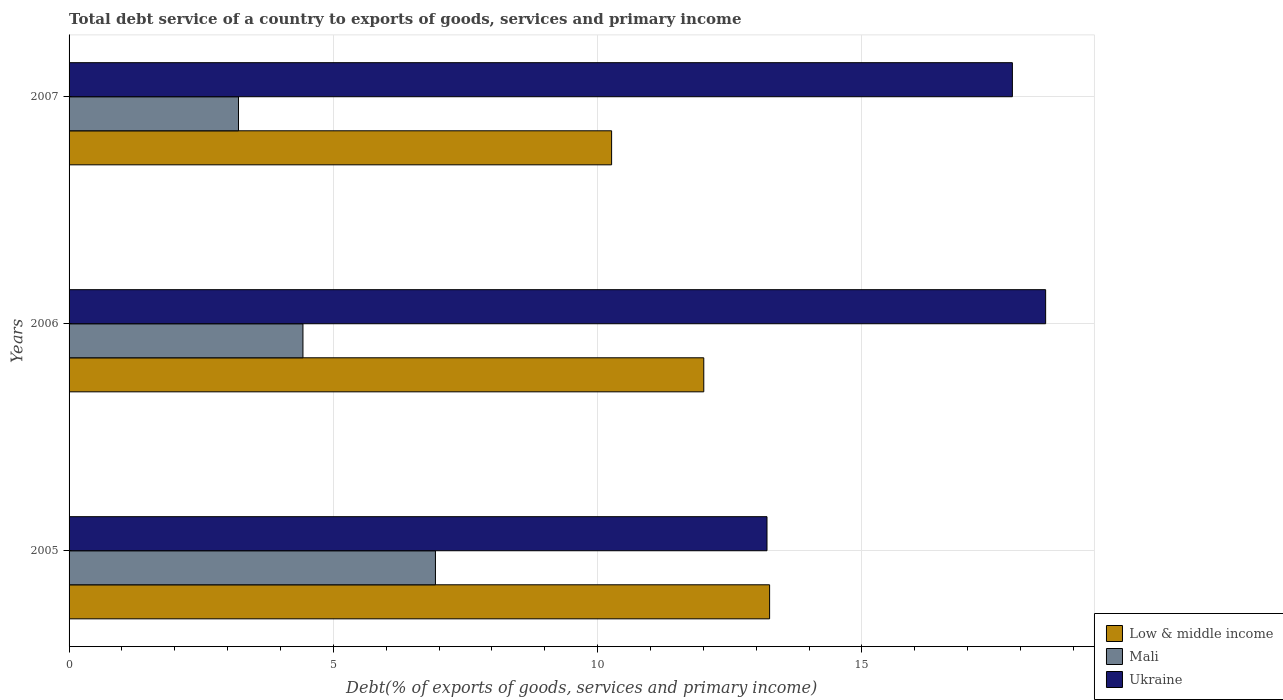How many different coloured bars are there?
Provide a succinct answer. 3. Are the number of bars per tick equal to the number of legend labels?
Provide a succinct answer. Yes. How many bars are there on the 1st tick from the top?
Your response must be concise. 3. What is the label of the 2nd group of bars from the top?
Your answer should be compact. 2006. In how many cases, is the number of bars for a given year not equal to the number of legend labels?
Offer a terse response. 0. What is the total debt service in Ukraine in 2007?
Make the answer very short. 17.85. Across all years, what is the maximum total debt service in Low & middle income?
Your answer should be very brief. 13.25. Across all years, what is the minimum total debt service in Ukraine?
Keep it short and to the point. 13.2. What is the total total debt service in Ukraine in the graph?
Your answer should be very brief. 49.52. What is the difference between the total debt service in Low & middle income in 2006 and that in 2007?
Your answer should be compact. 1.74. What is the difference between the total debt service in Mali in 2006 and the total debt service in Low & middle income in 2005?
Provide a succinct answer. -8.83. What is the average total debt service in Low & middle income per year?
Your answer should be very brief. 11.84. In the year 2006, what is the difference between the total debt service in Mali and total debt service in Low & middle income?
Your answer should be very brief. -7.58. What is the ratio of the total debt service in Ukraine in 2005 to that in 2006?
Make the answer very short. 0.71. Is the total debt service in Low & middle income in 2005 less than that in 2006?
Provide a short and direct response. No. What is the difference between the highest and the second highest total debt service in Low & middle income?
Offer a very short reply. 1.25. What is the difference between the highest and the lowest total debt service in Ukraine?
Make the answer very short. 5.27. What does the 2nd bar from the top in 2005 represents?
Offer a very short reply. Mali. What does the 3rd bar from the bottom in 2006 represents?
Give a very brief answer. Ukraine. Is it the case that in every year, the sum of the total debt service in Ukraine and total debt service in Mali is greater than the total debt service in Low & middle income?
Your answer should be compact. Yes. How many bars are there?
Give a very brief answer. 9. How many years are there in the graph?
Provide a short and direct response. 3. Does the graph contain grids?
Make the answer very short. Yes. Where does the legend appear in the graph?
Ensure brevity in your answer.  Bottom right. How are the legend labels stacked?
Make the answer very short. Vertical. What is the title of the graph?
Make the answer very short. Total debt service of a country to exports of goods, services and primary income. What is the label or title of the X-axis?
Provide a short and direct response. Debt(% of exports of goods, services and primary income). What is the label or title of the Y-axis?
Your answer should be very brief. Years. What is the Debt(% of exports of goods, services and primary income) in Low & middle income in 2005?
Your response must be concise. 13.25. What is the Debt(% of exports of goods, services and primary income) in Mali in 2005?
Your answer should be very brief. 6.93. What is the Debt(% of exports of goods, services and primary income) in Ukraine in 2005?
Provide a succinct answer. 13.2. What is the Debt(% of exports of goods, services and primary income) in Low & middle income in 2006?
Make the answer very short. 12.01. What is the Debt(% of exports of goods, services and primary income) in Mali in 2006?
Ensure brevity in your answer.  4.42. What is the Debt(% of exports of goods, services and primary income) in Ukraine in 2006?
Ensure brevity in your answer.  18.48. What is the Debt(% of exports of goods, services and primary income) in Low & middle income in 2007?
Give a very brief answer. 10.26. What is the Debt(% of exports of goods, services and primary income) in Mali in 2007?
Give a very brief answer. 3.2. What is the Debt(% of exports of goods, services and primary income) in Ukraine in 2007?
Keep it short and to the point. 17.85. Across all years, what is the maximum Debt(% of exports of goods, services and primary income) of Low & middle income?
Keep it short and to the point. 13.25. Across all years, what is the maximum Debt(% of exports of goods, services and primary income) of Mali?
Offer a terse response. 6.93. Across all years, what is the maximum Debt(% of exports of goods, services and primary income) of Ukraine?
Your answer should be compact. 18.48. Across all years, what is the minimum Debt(% of exports of goods, services and primary income) of Low & middle income?
Your answer should be compact. 10.26. Across all years, what is the minimum Debt(% of exports of goods, services and primary income) in Mali?
Your response must be concise. 3.2. Across all years, what is the minimum Debt(% of exports of goods, services and primary income) of Ukraine?
Your answer should be very brief. 13.2. What is the total Debt(% of exports of goods, services and primary income) in Low & middle income in the graph?
Ensure brevity in your answer.  35.52. What is the total Debt(% of exports of goods, services and primary income) of Mali in the graph?
Your response must be concise. 14.56. What is the total Debt(% of exports of goods, services and primary income) of Ukraine in the graph?
Keep it short and to the point. 49.52. What is the difference between the Debt(% of exports of goods, services and primary income) in Low & middle income in 2005 and that in 2006?
Ensure brevity in your answer.  1.25. What is the difference between the Debt(% of exports of goods, services and primary income) in Mali in 2005 and that in 2006?
Ensure brevity in your answer.  2.51. What is the difference between the Debt(% of exports of goods, services and primary income) in Ukraine in 2005 and that in 2006?
Keep it short and to the point. -5.27. What is the difference between the Debt(% of exports of goods, services and primary income) of Low & middle income in 2005 and that in 2007?
Offer a very short reply. 2.99. What is the difference between the Debt(% of exports of goods, services and primary income) in Mali in 2005 and that in 2007?
Your answer should be very brief. 3.73. What is the difference between the Debt(% of exports of goods, services and primary income) in Ukraine in 2005 and that in 2007?
Offer a terse response. -4.64. What is the difference between the Debt(% of exports of goods, services and primary income) in Low & middle income in 2006 and that in 2007?
Offer a terse response. 1.74. What is the difference between the Debt(% of exports of goods, services and primary income) in Mali in 2006 and that in 2007?
Keep it short and to the point. 1.22. What is the difference between the Debt(% of exports of goods, services and primary income) of Ukraine in 2006 and that in 2007?
Your answer should be compact. 0.63. What is the difference between the Debt(% of exports of goods, services and primary income) of Low & middle income in 2005 and the Debt(% of exports of goods, services and primary income) of Mali in 2006?
Your answer should be very brief. 8.83. What is the difference between the Debt(% of exports of goods, services and primary income) in Low & middle income in 2005 and the Debt(% of exports of goods, services and primary income) in Ukraine in 2006?
Provide a succinct answer. -5.22. What is the difference between the Debt(% of exports of goods, services and primary income) of Mali in 2005 and the Debt(% of exports of goods, services and primary income) of Ukraine in 2006?
Make the answer very short. -11.54. What is the difference between the Debt(% of exports of goods, services and primary income) of Low & middle income in 2005 and the Debt(% of exports of goods, services and primary income) of Mali in 2007?
Keep it short and to the point. 10.05. What is the difference between the Debt(% of exports of goods, services and primary income) in Low & middle income in 2005 and the Debt(% of exports of goods, services and primary income) in Ukraine in 2007?
Offer a very short reply. -4.59. What is the difference between the Debt(% of exports of goods, services and primary income) in Mali in 2005 and the Debt(% of exports of goods, services and primary income) in Ukraine in 2007?
Provide a succinct answer. -10.91. What is the difference between the Debt(% of exports of goods, services and primary income) in Low & middle income in 2006 and the Debt(% of exports of goods, services and primary income) in Mali in 2007?
Offer a very short reply. 8.8. What is the difference between the Debt(% of exports of goods, services and primary income) in Low & middle income in 2006 and the Debt(% of exports of goods, services and primary income) in Ukraine in 2007?
Make the answer very short. -5.84. What is the difference between the Debt(% of exports of goods, services and primary income) in Mali in 2006 and the Debt(% of exports of goods, services and primary income) in Ukraine in 2007?
Make the answer very short. -13.42. What is the average Debt(% of exports of goods, services and primary income) of Low & middle income per year?
Make the answer very short. 11.84. What is the average Debt(% of exports of goods, services and primary income) in Mali per year?
Your response must be concise. 4.85. What is the average Debt(% of exports of goods, services and primary income) of Ukraine per year?
Give a very brief answer. 16.51. In the year 2005, what is the difference between the Debt(% of exports of goods, services and primary income) of Low & middle income and Debt(% of exports of goods, services and primary income) of Mali?
Make the answer very short. 6.32. In the year 2005, what is the difference between the Debt(% of exports of goods, services and primary income) in Low & middle income and Debt(% of exports of goods, services and primary income) in Ukraine?
Provide a short and direct response. 0.05. In the year 2005, what is the difference between the Debt(% of exports of goods, services and primary income) of Mali and Debt(% of exports of goods, services and primary income) of Ukraine?
Keep it short and to the point. -6.27. In the year 2006, what is the difference between the Debt(% of exports of goods, services and primary income) of Low & middle income and Debt(% of exports of goods, services and primary income) of Mali?
Your answer should be compact. 7.58. In the year 2006, what is the difference between the Debt(% of exports of goods, services and primary income) in Low & middle income and Debt(% of exports of goods, services and primary income) in Ukraine?
Give a very brief answer. -6.47. In the year 2006, what is the difference between the Debt(% of exports of goods, services and primary income) of Mali and Debt(% of exports of goods, services and primary income) of Ukraine?
Ensure brevity in your answer.  -14.05. In the year 2007, what is the difference between the Debt(% of exports of goods, services and primary income) in Low & middle income and Debt(% of exports of goods, services and primary income) in Mali?
Your response must be concise. 7.06. In the year 2007, what is the difference between the Debt(% of exports of goods, services and primary income) in Low & middle income and Debt(% of exports of goods, services and primary income) in Ukraine?
Your response must be concise. -7.58. In the year 2007, what is the difference between the Debt(% of exports of goods, services and primary income) of Mali and Debt(% of exports of goods, services and primary income) of Ukraine?
Make the answer very short. -14.64. What is the ratio of the Debt(% of exports of goods, services and primary income) in Low & middle income in 2005 to that in 2006?
Ensure brevity in your answer.  1.1. What is the ratio of the Debt(% of exports of goods, services and primary income) of Mali in 2005 to that in 2006?
Your response must be concise. 1.57. What is the ratio of the Debt(% of exports of goods, services and primary income) of Ukraine in 2005 to that in 2006?
Your answer should be very brief. 0.71. What is the ratio of the Debt(% of exports of goods, services and primary income) of Low & middle income in 2005 to that in 2007?
Make the answer very short. 1.29. What is the ratio of the Debt(% of exports of goods, services and primary income) of Mali in 2005 to that in 2007?
Make the answer very short. 2.16. What is the ratio of the Debt(% of exports of goods, services and primary income) in Ukraine in 2005 to that in 2007?
Provide a succinct answer. 0.74. What is the ratio of the Debt(% of exports of goods, services and primary income) of Low & middle income in 2006 to that in 2007?
Your answer should be compact. 1.17. What is the ratio of the Debt(% of exports of goods, services and primary income) in Mali in 2006 to that in 2007?
Ensure brevity in your answer.  1.38. What is the ratio of the Debt(% of exports of goods, services and primary income) in Ukraine in 2006 to that in 2007?
Provide a short and direct response. 1.04. What is the difference between the highest and the second highest Debt(% of exports of goods, services and primary income) in Low & middle income?
Make the answer very short. 1.25. What is the difference between the highest and the second highest Debt(% of exports of goods, services and primary income) of Mali?
Your answer should be compact. 2.51. What is the difference between the highest and the second highest Debt(% of exports of goods, services and primary income) of Ukraine?
Make the answer very short. 0.63. What is the difference between the highest and the lowest Debt(% of exports of goods, services and primary income) of Low & middle income?
Your response must be concise. 2.99. What is the difference between the highest and the lowest Debt(% of exports of goods, services and primary income) in Mali?
Offer a very short reply. 3.73. What is the difference between the highest and the lowest Debt(% of exports of goods, services and primary income) in Ukraine?
Provide a succinct answer. 5.27. 